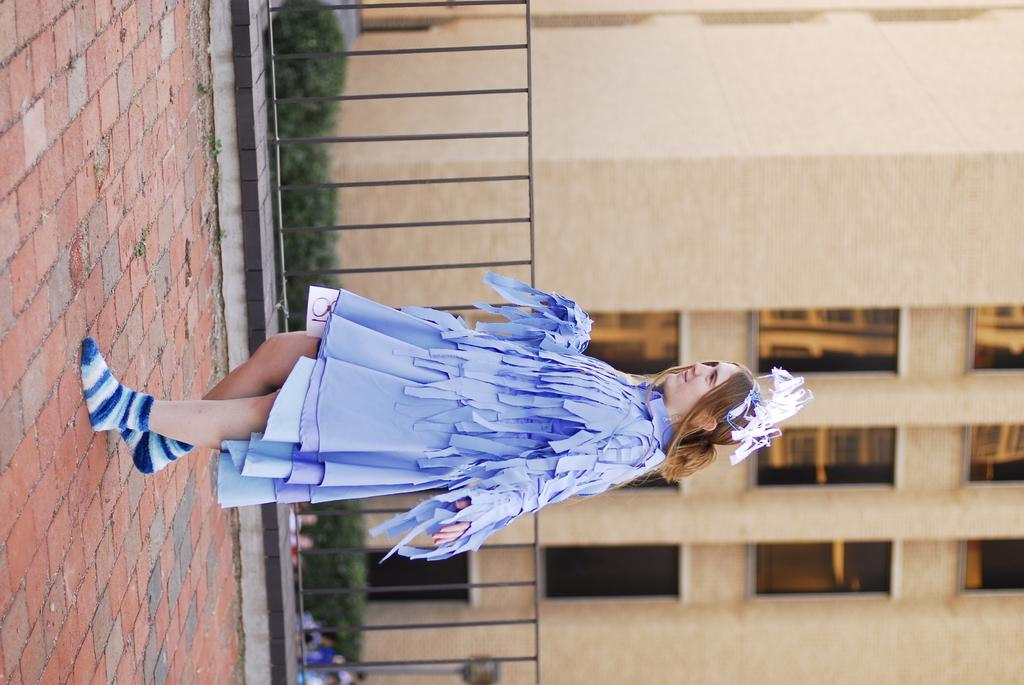What is the main subject of the image? The main subject of the image is a woman. What can be seen in the background of the image? In the background of the image, there is a fence, plants, people, and a building. What type of road can be seen in the image? There is no road present in the image. What is the woman thinking about in the image? The image does not provide information about the woman's thoughts, so it cannot be determined from the picture. 